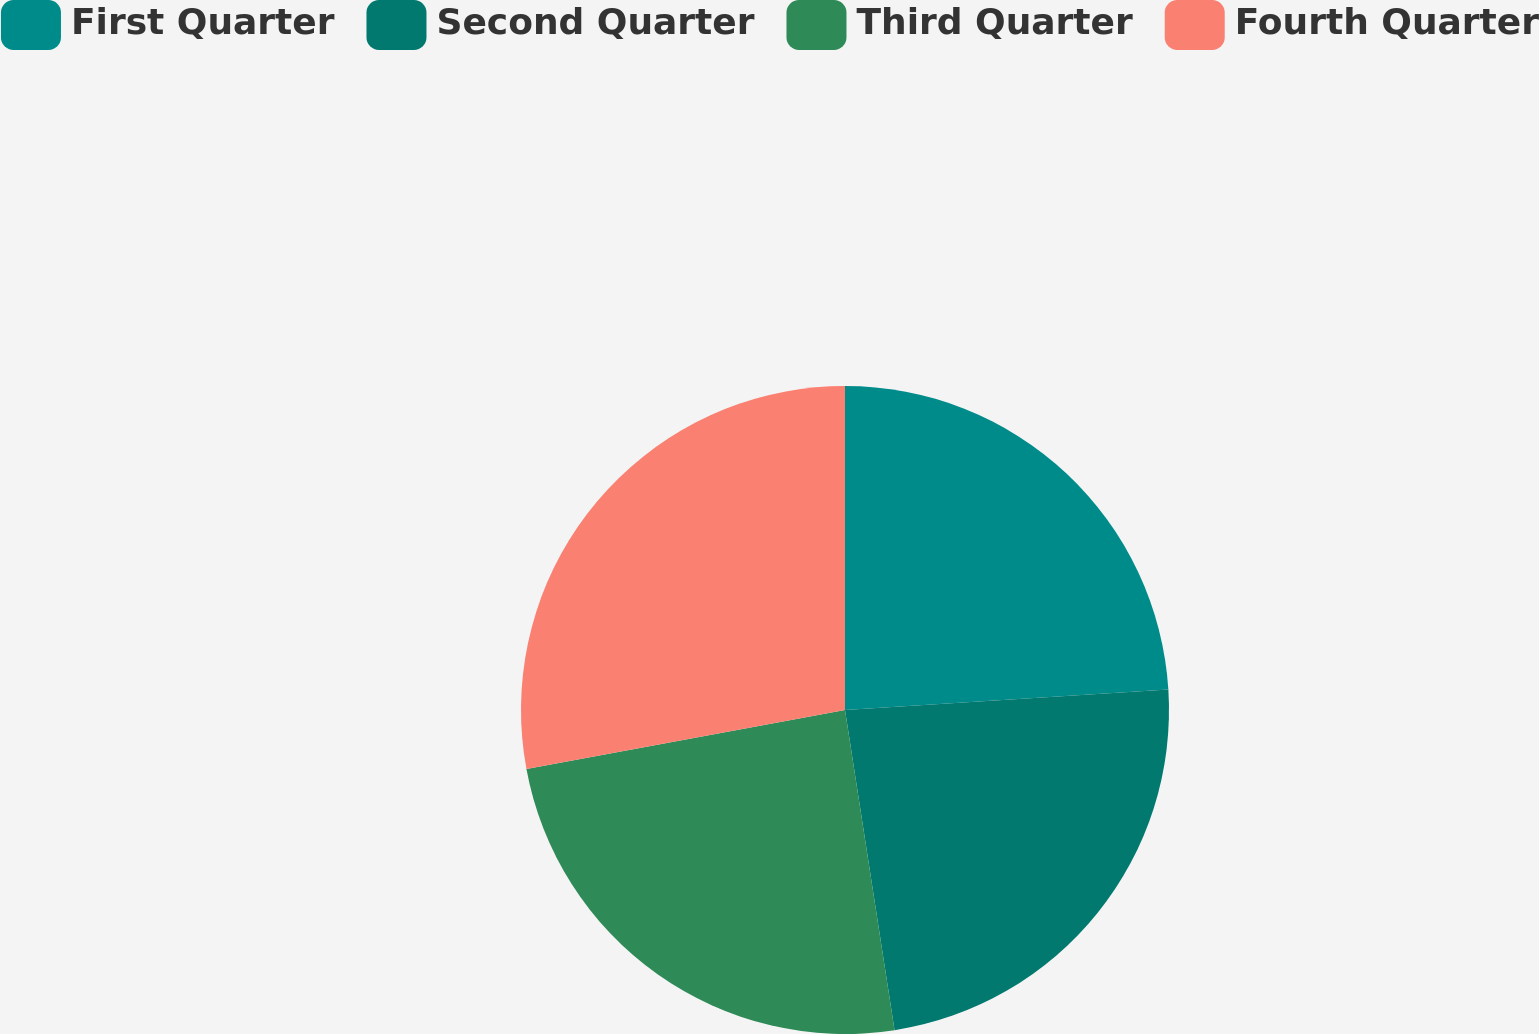Convert chart to OTSL. <chart><loc_0><loc_0><loc_500><loc_500><pie_chart><fcel>First Quarter<fcel>Second Quarter<fcel>Third Quarter<fcel>Fourth Quarter<nl><fcel>24.0%<fcel>23.56%<fcel>24.53%<fcel>27.92%<nl></chart> 